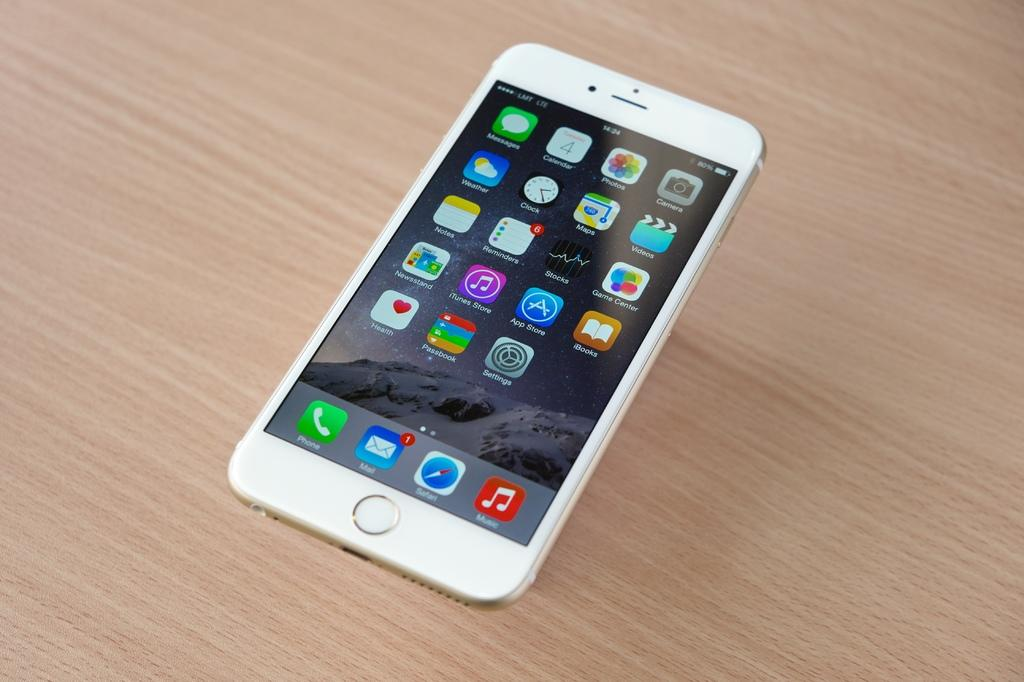What type of surface is visible in the image? There is a wooden surface in the image. What is placed on the wooden surface? There is a mobile on the wooden surface. What can be seen on the mobile's display? The mobile's display shows applications. How is the glue being used in the image? There is no glue present in the image. What type of board is being used to display the applications? There is no board present in the image; the applications are displayed on a mobile. 